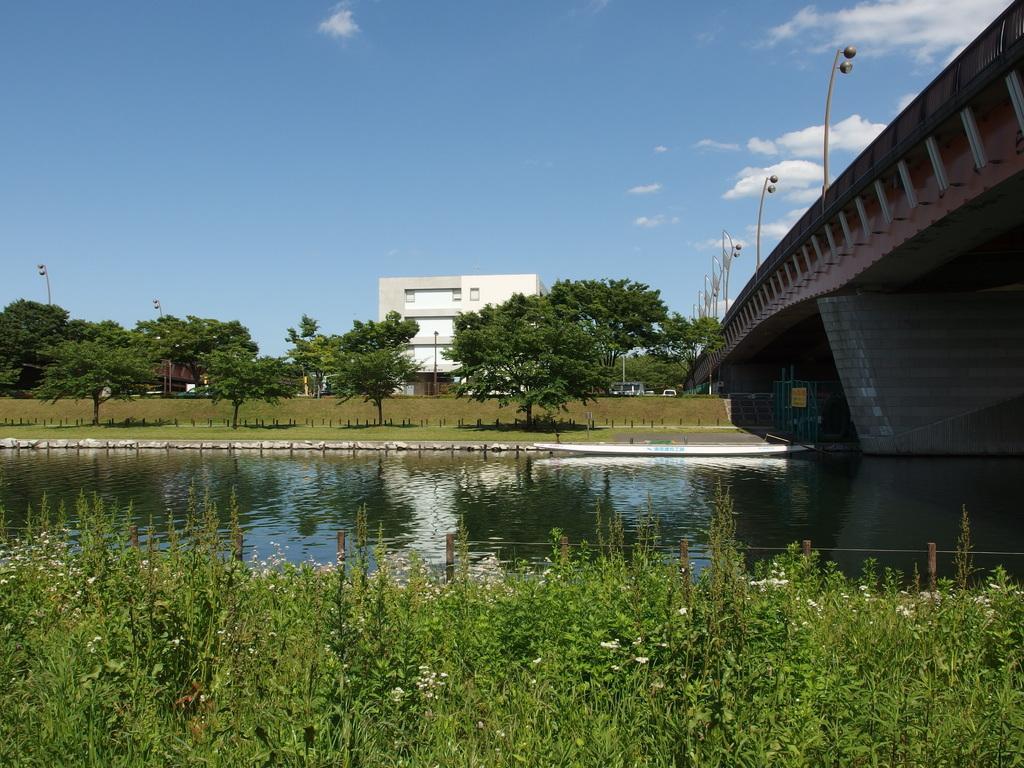In one or two sentences, can you explain what this image depicts? In this image, I can see the trees, plants with flowers, a building and there is water. On the right side of the image, I can see the street lights on a bridge. In the background, there is the sky. 